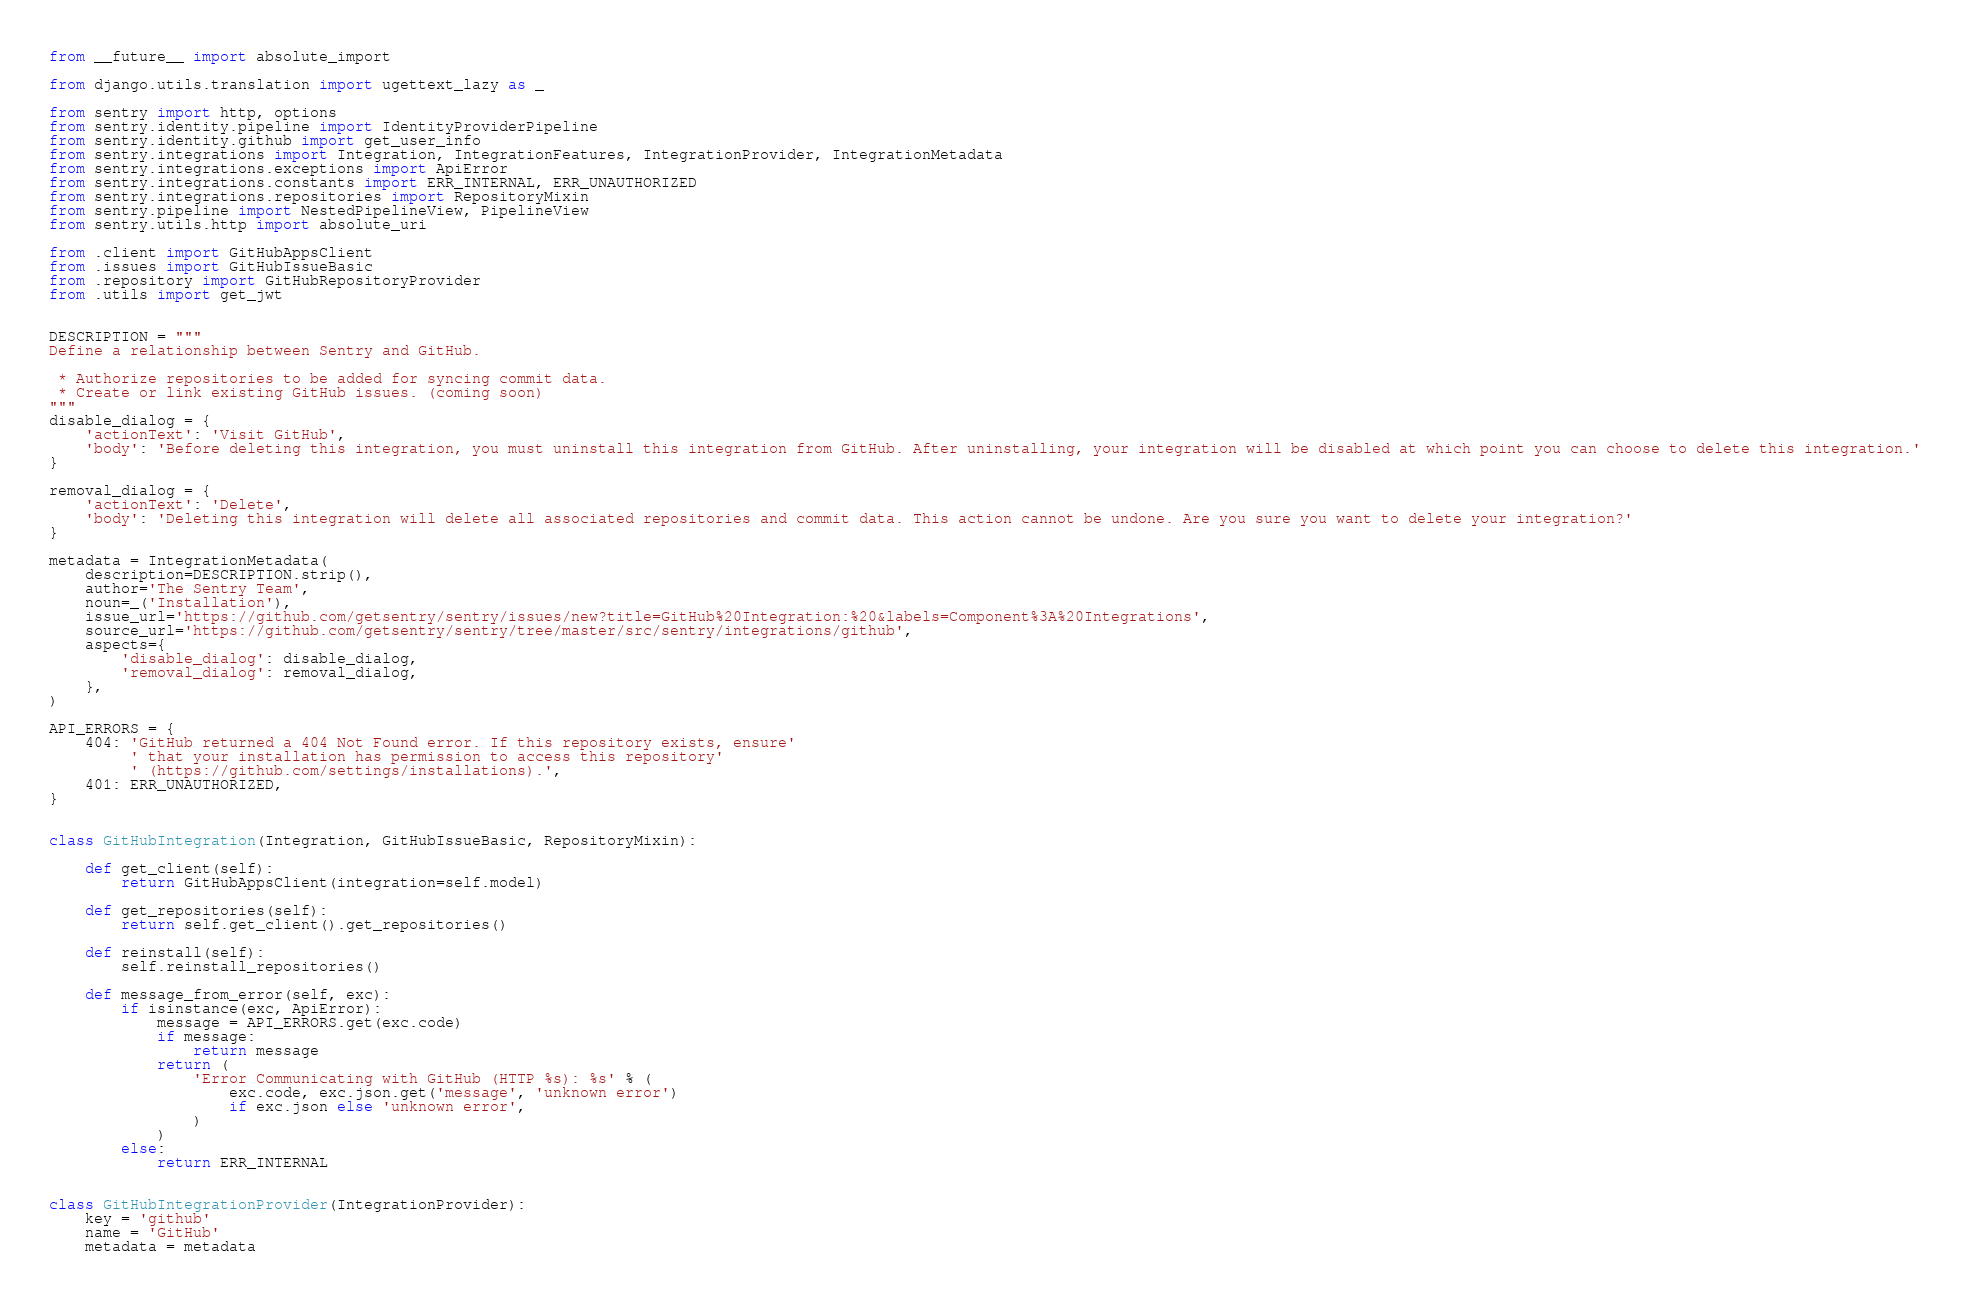Convert code to text. <code><loc_0><loc_0><loc_500><loc_500><_Python_>from __future__ import absolute_import

from django.utils.translation import ugettext_lazy as _

from sentry import http, options
from sentry.identity.pipeline import IdentityProviderPipeline
from sentry.identity.github import get_user_info
from sentry.integrations import Integration, IntegrationFeatures, IntegrationProvider, IntegrationMetadata
from sentry.integrations.exceptions import ApiError
from sentry.integrations.constants import ERR_INTERNAL, ERR_UNAUTHORIZED
from sentry.integrations.repositories import RepositoryMixin
from sentry.pipeline import NestedPipelineView, PipelineView
from sentry.utils.http import absolute_uri

from .client import GitHubAppsClient
from .issues import GitHubIssueBasic
from .repository import GitHubRepositoryProvider
from .utils import get_jwt


DESCRIPTION = """
Define a relationship between Sentry and GitHub.

 * Authorize repositories to be added for syncing commit data.
 * Create or link existing GitHub issues. (coming soon)
"""
disable_dialog = {
    'actionText': 'Visit GitHub',
    'body': 'Before deleting this integration, you must uninstall this integration from GitHub. After uninstalling, your integration will be disabled at which point you can choose to delete this integration.'
}

removal_dialog = {
    'actionText': 'Delete',
    'body': 'Deleting this integration will delete all associated repositories and commit data. This action cannot be undone. Are you sure you want to delete your integration?'
}

metadata = IntegrationMetadata(
    description=DESCRIPTION.strip(),
    author='The Sentry Team',
    noun=_('Installation'),
    issue_url='https://github.com/getsentry/sentry/issues/new?title=GitHub%20Integration:%20&labels=Component%3A%20Integrations',
    source_url='https://github.com/getsentry/sentry/tree/master/src/sentry/integrations/github',
    aspects={
        'disable_dialog': disable_dialog,
        'removal_dialog': removal_dialog,
    },
)

API_ERRORS = {
    404: 'GitHub returned a 404 Not Found error. If this repository exists, ensure'
         ' that your installation has permission to access this repository'
         ' (https://github.com/settings/installations).',
    401: ERR_UNAUTHORIZED,
}


class GitHubIntegration(Integration, GitHubIssueBasic, RepositoryMixin):

    def get_client(self):
        return GitHubAppsClient(integration=self.model)

    def get_repositories(self):
        return self.get_client().get_repositories()

    def reinstall(self):
        self.reinstall_repositories()

    def message_from_error(self, exc):
        if isinstance(exc, ApiError):
            message = API_ERRORS.get(exc.code)
            if message:
                return message
            return (
                'Error Communicating with GitHub (HTTP %s): %s' % (
                    exc.code, exc.json.get('message', 'unknown error')
                    if exc.json else 'unknown error',
                )
            )
        else:
            return ERR_INTERNAL


class GitHubIntegrationProvider(IntegrationProvider):
    key = 'github'
    name = 'GitHub'
    metadata = metadata</code> 